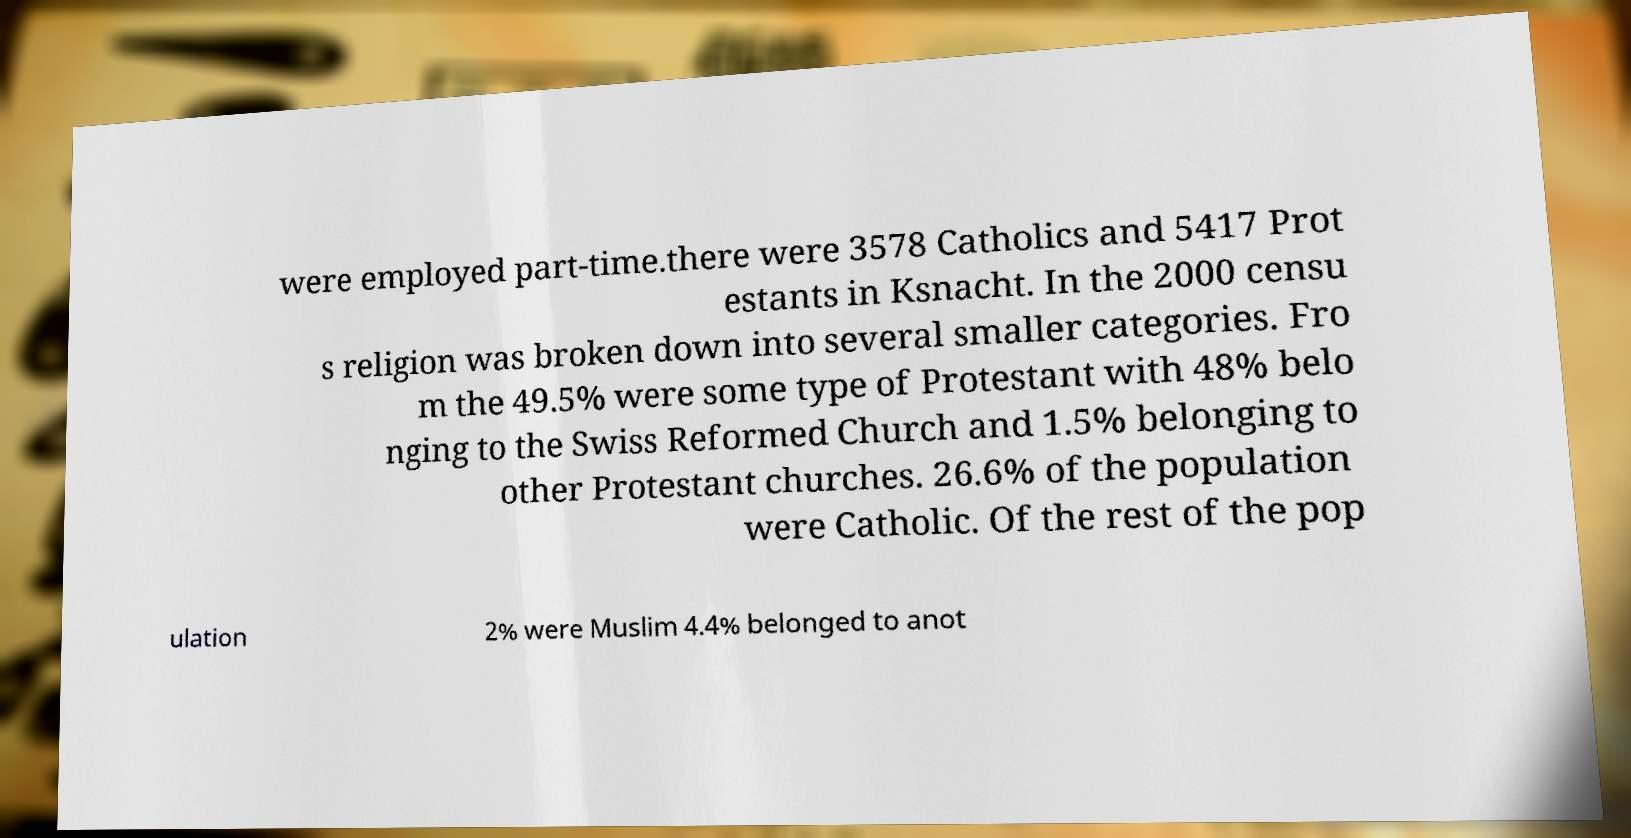What messages or text are displayed in this image? I need them in a readable, typed format. were employed part-time.there were 3578 Catholics and 5417 Prot estants in Ksnacht. In the 2000 censu s religion was broken down into several smaller categories. Fro m the 49.5% were some type of Protestant with 48% belo nging to the Swiss Reformed Church and 1.5% belonging to other Protestant churches. 26.6% of the population were Catholic. Of the rest of the pop ulation 2% were Muslim 4.4% belonged to anot 